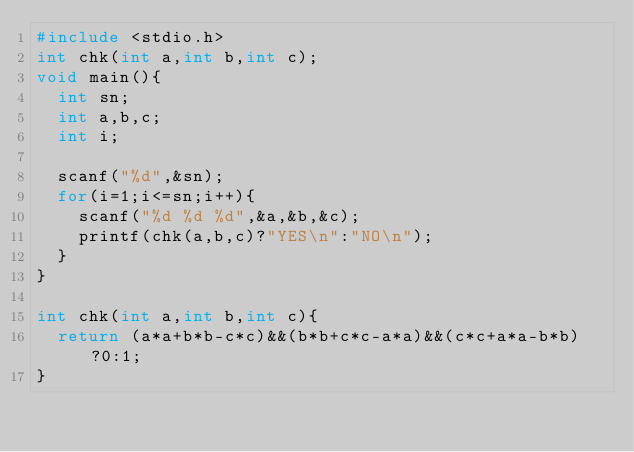Convert code to text. <code><loc_0><loc_0><loc_500><loc_500><_C_>#include <stdio.h>
int chk(int a,int b,int c);
void main(){
	int sn;
	int a,b,c;
	int i;

	scanf("%d",&sn);
	for(i=1;i<=sn;i++){
		scanf("%d %d %d",&a,&b,&c);
		printf(chk(a,b,c)?"YES\n":"NO\n");
	}
}

int chk(int a,int b,int c){
	return (a*a+b*b-c*c)&&(b*b+c*c-a*a)&&(c*c+a*a-b*b)?0:1;
}</code> 